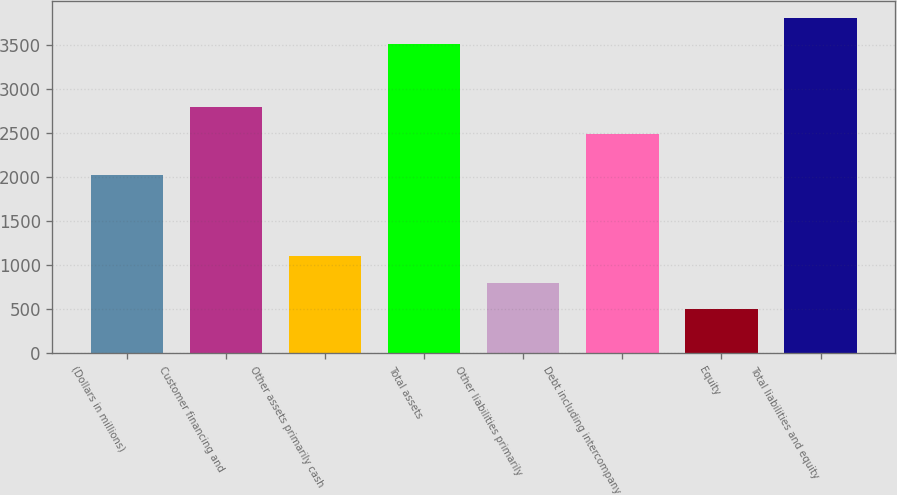<chart> <loc_0><loc_0><loc_500><loc_500><bar_chart><fcel>(Dollars in millions)<fcel>Customer financing and<fcel>Other assets primarily cash<fcel>Total assets<fcel>Other liabilities primarily<fcel>Debt including intercompany<fcel>Equity<fcel>Total liabilities and equity<nl><fcel>2018<fcel>2790<fcel>1099<fcel>3507<fcel>798<fcel>2487<fcel>497<fcel>3808<nl></chart> 